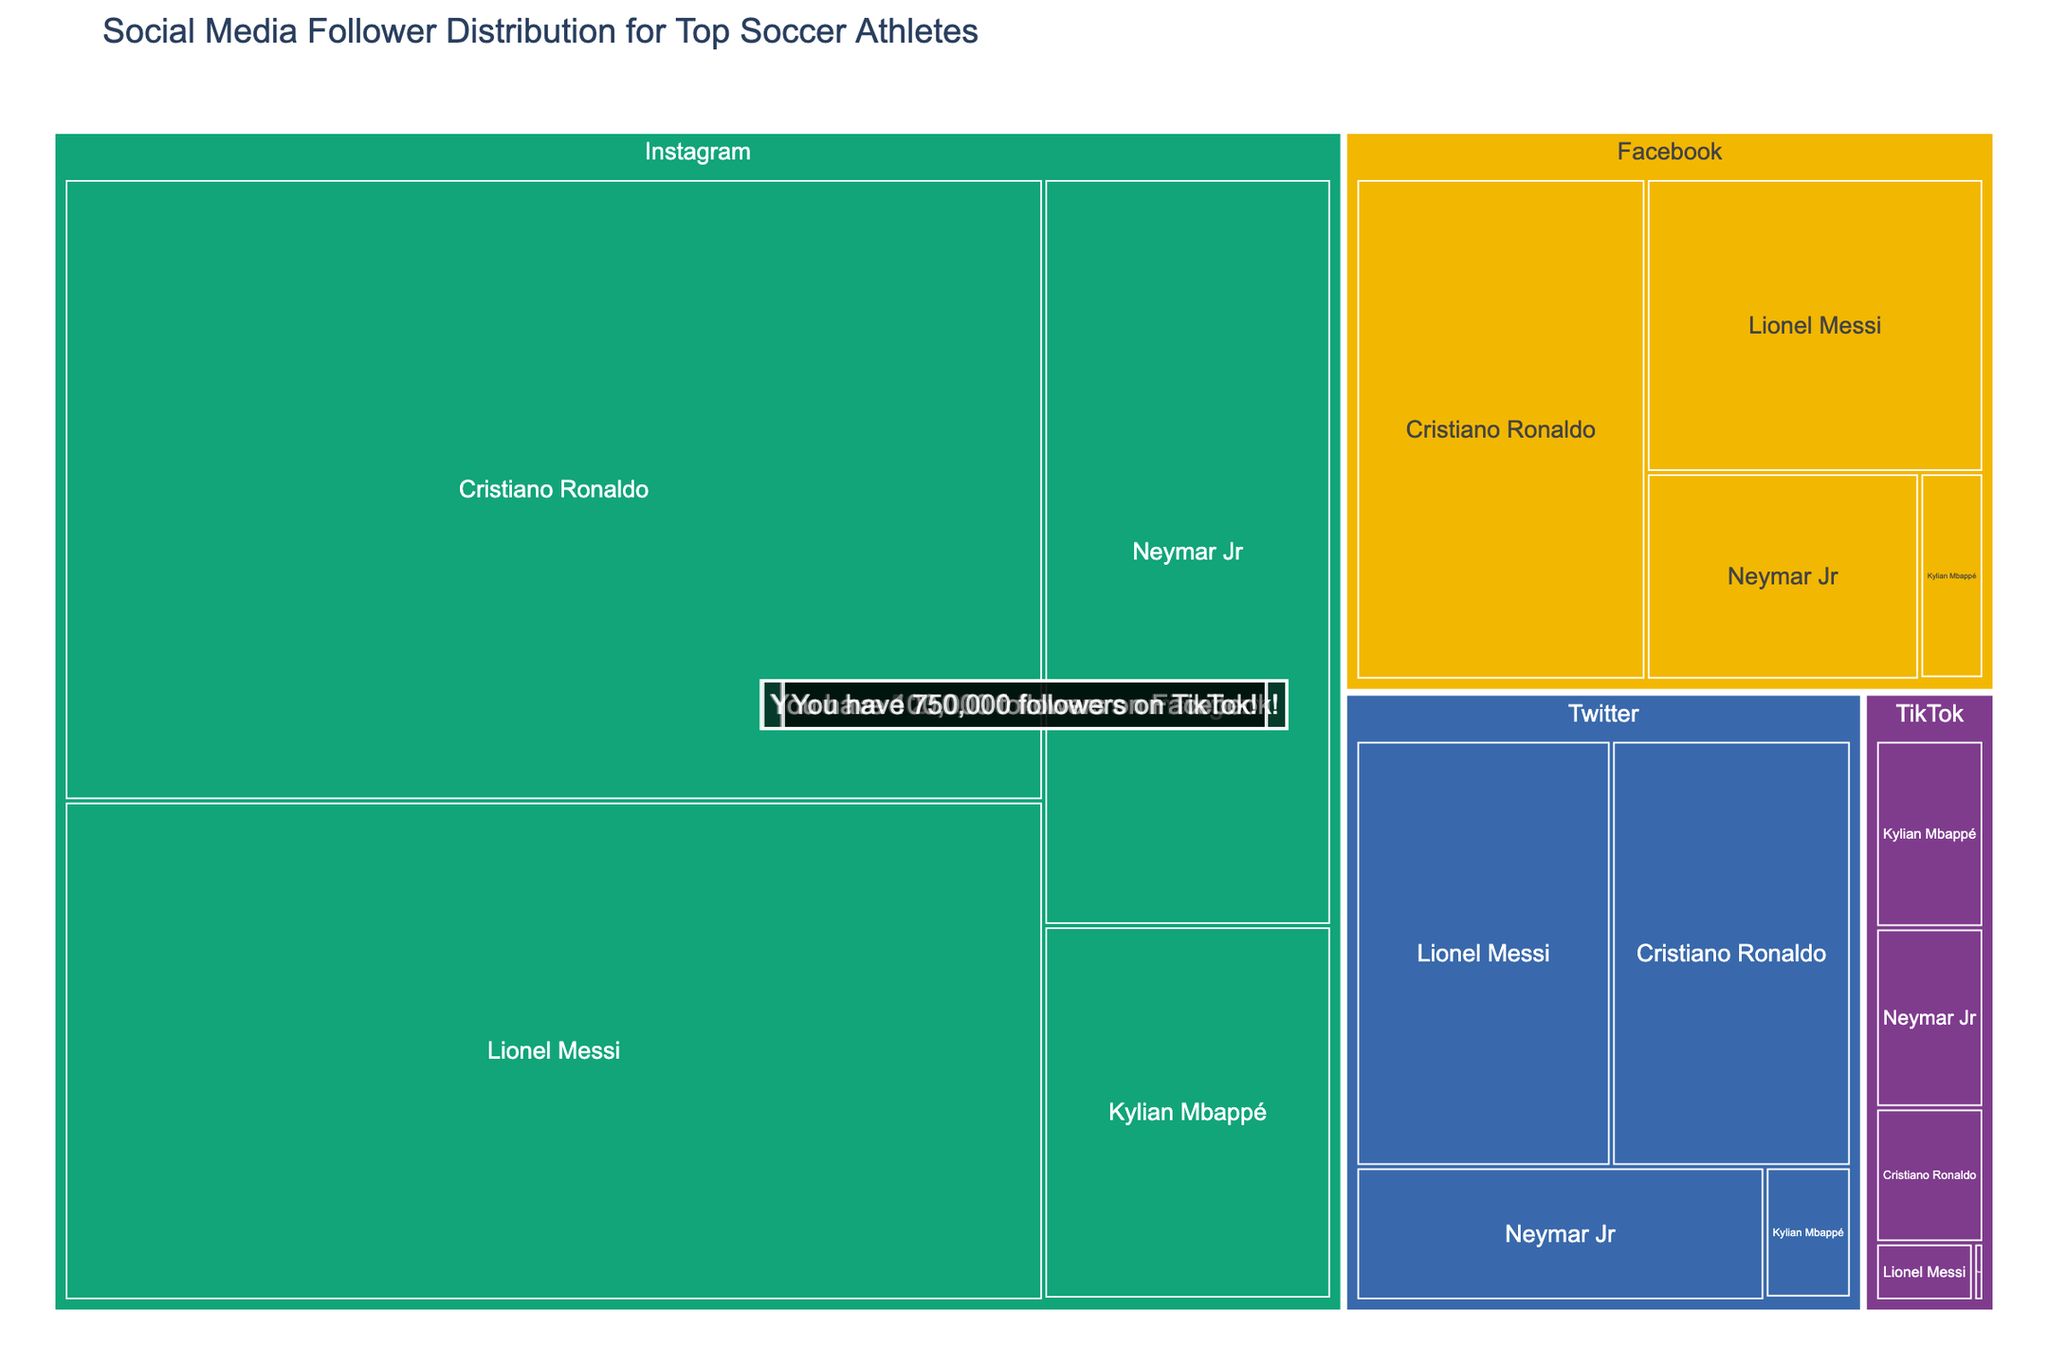What is the title of the treemap? The title is typically displayed at the top of the treemap and gives the viewer a summary of what the visualization is about.
Answer: Social Media Follower Distribution for Top Soccer Athletes Which platform has the highest total number of followers for Cristiano Ronaldo? By summing up the followers of Cristiano Ronaldo across all platforms and comparing them, we see that Instagram has the highest number of followers for him.
Answer: Instagram How many platforms are represented in the treemap? Each platform is a distinct color-coded section in the treemap; counting them gives us the number of platforms.
Answer: 4 Which athlete has more followers combined on Instagram and Facebook compared to the others? Adding Instagram and Facebook followers of each athlete and comparing gives us: Cristiano Ronaldo: 595,000,000 + 154,000,000 = 749,000,000, Lionel Messi: 478,000,000 + 105,000,000 = 583,000,000, Neymar Jr: 210,000,000 + 60,000,000 = 270,000,000, Kylian Mbappé: 105,000,000 + 14,000,000= 119,000,000, You: 500,000 + 100,000 = 600,000.
Answer: Cristiano Ronaldo Which platform does "You" have the highest number of followers on? Looking at the individual highlight for "You" in the treemap, the highest number of followers is on TikTok.
Answer: TikTok What is the difference in followers between Lionel Messi and Neymar Jr on Twitter? Subtracting Neymar Jr's followers from Lionel Messi's on Twitter: 115,000,000 - 58,000,000 = 57,000,000.
Answer: 57,000,000 Are there more followers on Instagram or Facebook for Kylian Mbappé? Comparing the number of followers on Instagram and Facebook for Kylian Mbappé shows more followers on Instagram (105,000,000) than on Facebook (14,000,000).
Answer: Instagram Which athlete has the fewest followers on TikTok? The treemap shows all athletes and their followers on TikTok; the one with the least is Lionel Messi with 7,000,000 followers.
Answer: Lionel Messi How does the total number of followers for Lionel Messi on all platforms compare to the total for Neymar Jr? Adding up all followers for each athlete: Lionel Messi: 478,000,000 + 115,000,000 + 105,000,000 + 7,000,000 = 705,000,000, Neymar Jr: 210,000,000 + 58,000,000 + 60,000,000 + 24,000,000 = 352,000,000. Lionel Messi has more followers overall.
Answer: Lionel Messi 